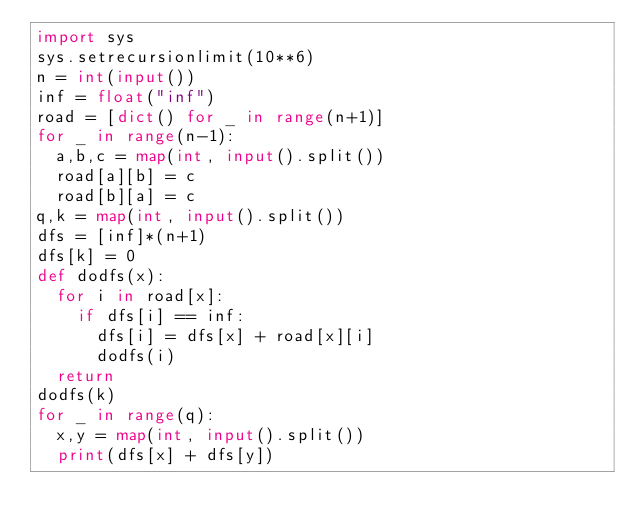Convert code to text. <code><loc_0><loc_0><loc_500><loc_500><_Python_>import sys
sys.setrecursionlimit(10**6)
n = int(input())
inf = float("inf")
road = [dict() for _ in range(n+1)]
for _ in range(n-1):
  a,b,c = map(int, input().split())
  road[a][b] = c
  road[b][a] = c
q,k = map(int, input().split())
dfs = [inf]*(n+1)
dfs[k] = 0
def dodfs(x):
  for i in road[x]:
    if dfs[i] == inf:
      dfs[i] = dfs[x] + road[x][i]
      dodfs(i)
  return   
dodfs(k)
for _ in range(q):
  x,y = map(int, input().split())
  print(dfs[x] + dfs[y])</code> 